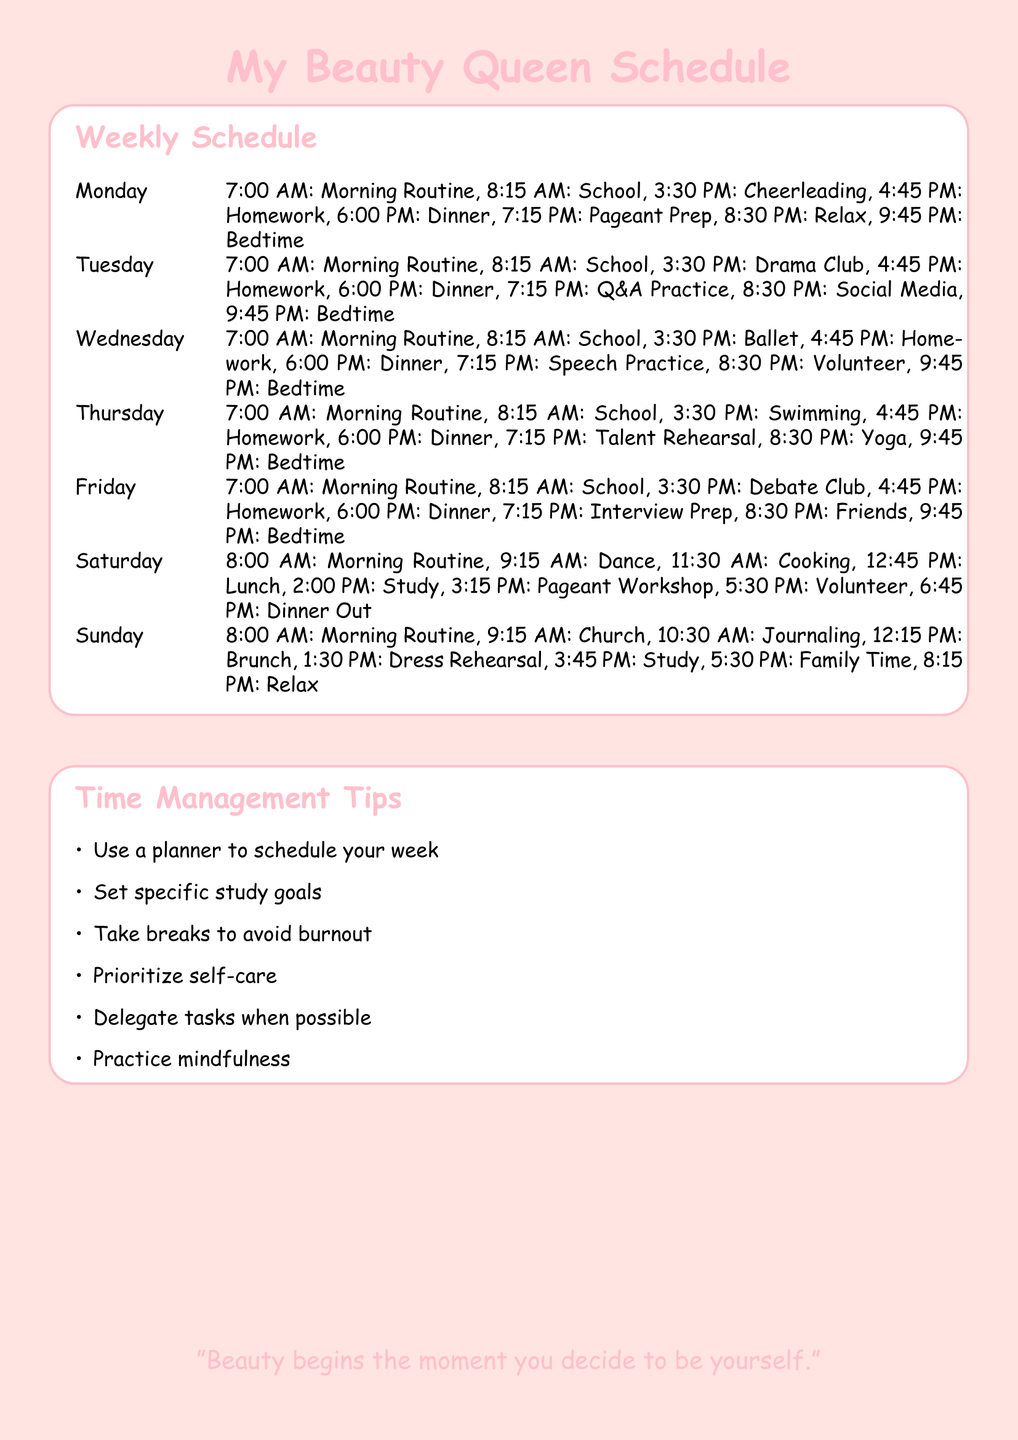What time does school start on Monday? The document specifies that school starts at 8:15 AM on Monday.
Answer: 8:15 AM What activity is scheduled after homework on Tuesday? According to the timeline, Q&A Practice is scheduled after homework on Tuesday.
Answer: Q&A Practice How many extracurricular activities are listed for Saturday? The schedule shows 5 extracurricular activities listed for Saturday.
Answer: 5 What is the last activity listed on Sunday? The last activity on Sunday is Relax, scheduled for 8:15 PM.
Answer: Relax What is one time management tip provided in the document? The document offers several tips, including 'Use a planner to schedule your week'.
Answer: Use a planner to schedule your week Which day has a dance session scheduled, and what time does it start? Saturday has a dance session, which starts at 9:15 AM.
Answer: 9:15 AM How long is the morning routine each day generally? The morning routine typically starts at 7:00 AM on weekdays but at 8:00 AM on weekends, indicating a general duration of 1 hour for weekdays.
Answer: 1 hour What is the activity listed at 7:15 PM on Thursday? The schedule indicates that Talent Rehearsal is the activity at 7:15 PM on Thursday.
Answer: Talent Rehearsal What word describes the color used for the document's background? The color used for the background of the document is described as light pink.
Answer: light pink 